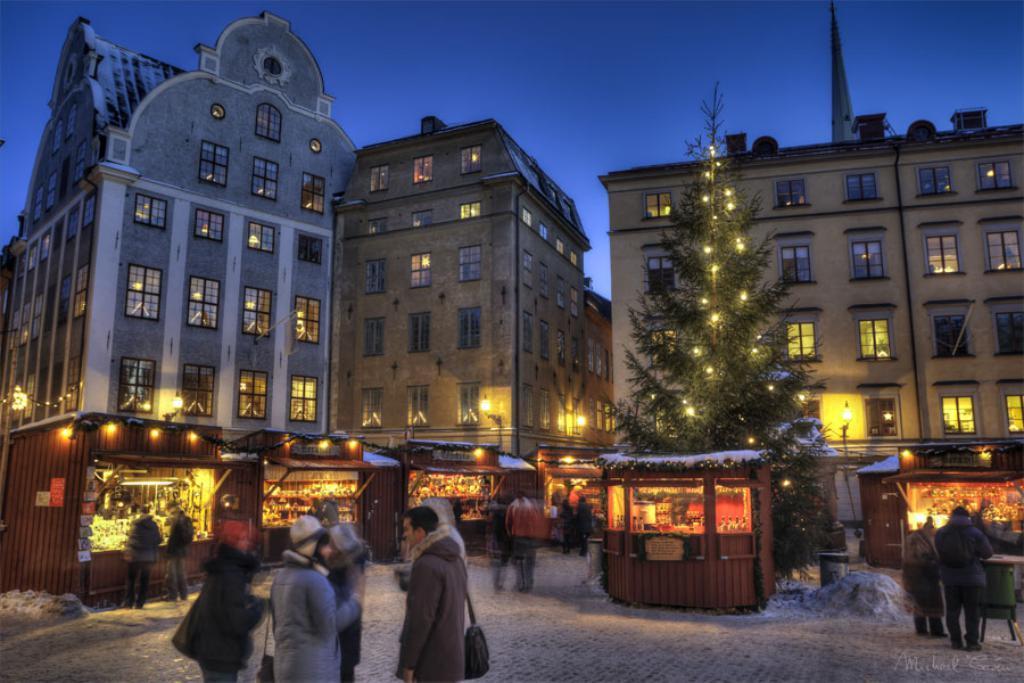Can you describe this image briefly? In the image we can see there are buildings and there are stalls and shop. There are people standing on the road and few people are near the stalls. There is a christmas tree decorated with lights. 